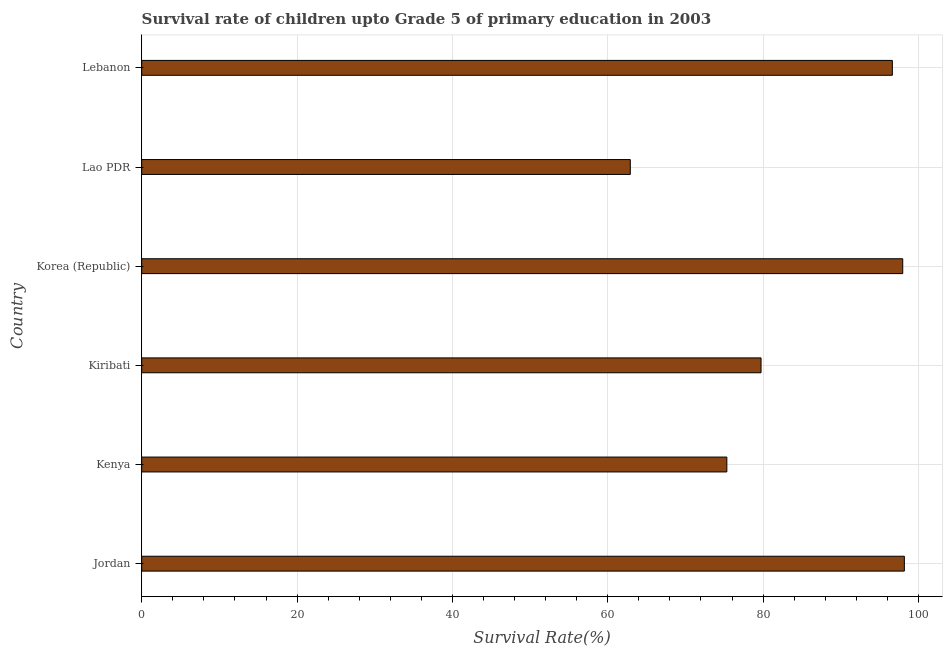What is the title of the graph?
Your answer should be very brief. Survival rate of children upto Grade 5 of primary education in 2003 . What is the label or title of the X-axis?
Provide a succinct answer. Survival Rate(%). What is the label or title of the Y-axis?
Make the answer very short. Country. What is the survival rate in Jordan?
Your response must be concise. 98.18. Across all countries, what is the maximum survival rate?
Provide a short and direct response. 98.18. Across all countries, what is the minimum survival rate?
Provide a succinct answer. 62.9. In which country was the survival rate maximum?
Make the answer very short. Jordan. In which country was the survival rate minimum?
Keep it short and to the point. Lao PDR. What is the sum of the survival rate?
Your response must be concise. 510.76. What is the difference between the survival rate in Kenya and Korea (Republic)?
Offer a terse response. -22.64. What is the average survival rate per country?
Provide a succinct answer. 85.13. What is the median survival rate?
Your response must be concise. 88.19. What is the ratio of the survival rate in Jordan to that in Korea (Republic)?
Provide a succinct answer. 1. Is the difference between the survival rate in Kenya and Korea (Republic) greater than the difference between any two countries?
Provide a short and direct response. No. What is the difference between the highest and the second highest survival rate?
Offer a very short reply. 0.21. What is the difference between the highest and the lowest survival rate?
Your answer should be compact. 35.28. In how many countries, is the survival rate greater than the average survival rate taken over all countries?
Give a very brief answer. 3. How many countries are there in the graph?
Offer a very short reply. 6. Are the values on the major ticks of X-axis written in scientific E-notation?
Provide a short and direct response. No. What is the Survival Rate(%) in Jordan?
Ensure brevity in your answer.  98.18. What is the Survival Rate(%) of Kenya?
Provide a short and direct response. 75.33. What is the Survival Rate(%) of Kiribati?
Keep it short and to the point. 79.73. What is the Survival Rate(%) in Korea (Republic)?
Your answer should be very brief. 97.98. What is the Survival Rate(%) in Lao PDR?
Provide a succinct answer. 62.9. What is the Survival Rate(%) in Lebanon?
Give a very brief answer. 96.64. What is the difference between the Survival Rate(%) in Jordan and Kenya?
Give a very brief answer. 22.85. What is the difference between the Survival Rate(%) in Jordan and Kiribati?
Your answer should be compact. 18.45. What is the difference between the Survival Rate(%) in Jordan and Korea (Republic)?
Your answer should be compact. 0.21. What is the difference between the Survival Rate(%) in Jordan and Lao PDR?
Your response must be concise. 35.28. What is the difference between the Survival Rate(%) in Jordan and Lebanon?
Make the answer very short. 1.54. What is the difference between the Survival Rate(%) in Kenya and Kiribati?
Offer a very short reply. -4.4. What is the difference between the Survival Rate(%) in Kenya and Korea (Republic)?
Give a very brief answer. -22.64. What is the difference between the Survival Rate(%) in Kenya and Lao PDR?
Keep it short and to the point. 12.43. What is the difference between the Survival Rate(%) in Kenya and Lebanon?
Your answer should be very brief. -21.31. What is the difference between the Survival Rate(%) in Kiribati and Korea (Republic)?
Provide a succinct answer. -18.24. What is the difference between the Survival Rate(%) in Kiribati and Lao PDR?
Give a very brief answer. 16.83. What is the difference between the Survival Rate(%) in Kiribati and Lebanon?
Ensure brevity in your answer.  -16.91. What is the difference between the Survival Rate(%) in Korea (Republic) and Lao PDR?
Give a very brief answer. 35.08. What is the difference between the Survival Rate(%) in Korea (Republic) and Lebanon?
Your answer should be very brief. 1.34. What is the difference between the Survival Rate(%) in Lao PDR and Lebanon?
Your answer should be compact. -33.74. What is the ratio of the Survival Rate(%) in Jordan to that in Kenya?
Your answer should be very brief. 1.3. What is the ratio of the Survival Rate(%) in Jordan to that in Kiribati?
Your response must be concise. 1.23. What is the ratio of the Survival Rate(%) in Jordan to that in Korea (Republic)?
Provide a succinct answer. 1. What is the ratio of the Survival Rate(%) in Jordan to that in Lao PDR?
Give a very brief answer. 1.56. What is the ratio of the Survival Rate(%) in Kenya to that in Kiribati?
Your response must be concise. 0.94. What is the ratio of the Survival Rate(%) in Kenya to that in Korea (Republic)?
Provide a short and direct response. 0.77. What is the ratio of the Survival Rate(%) in Kenya to that in Lao PDR?
Your response must be concise. 1.2. What is the ratio of the Survival Rate(%) in Kenya to that in Lebanon?
Ensure brevity in your answer.  0.78. What is the ratio of the Survival Rate(%) in Kiribati to that in Korea (Republic)?
Your answer should be compact. 0.81. What is the ratio of the Survival Rate(%) in Kiribati to that in Lao PDR?
Your response must be concise. 1.27. What is the ratio of the Survival Rate(%) in Kiribati to that in Lebanon?
Give a very brief answer. 0.82. What is the ratio of the Survival Rate(%) in Korea (Republic) to that in Lao PDR?
Ensure brevity in your answer.  1.56. What is the ratio of the Survival Rate(%) in Lao PDR to that in Lebanon?
Keep it short and to the point. 0.65. 